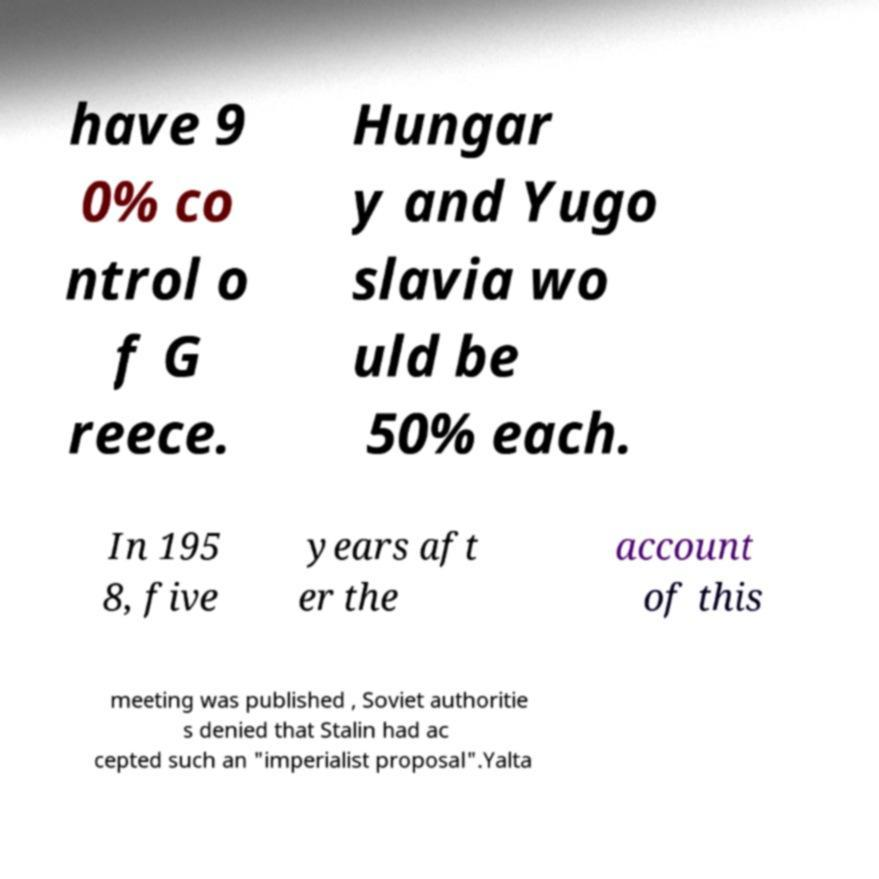Could you extract and type out the text from this image? have 9 0% co ntrol o f G reece. Hungar y and Yugo slavia wo uld be 50% each. In 195 8, five years aft er the account of this meeting was published , Soviet authoritie s denied that Stalin had ac cepted such an "imperialist proposal".Yalta 